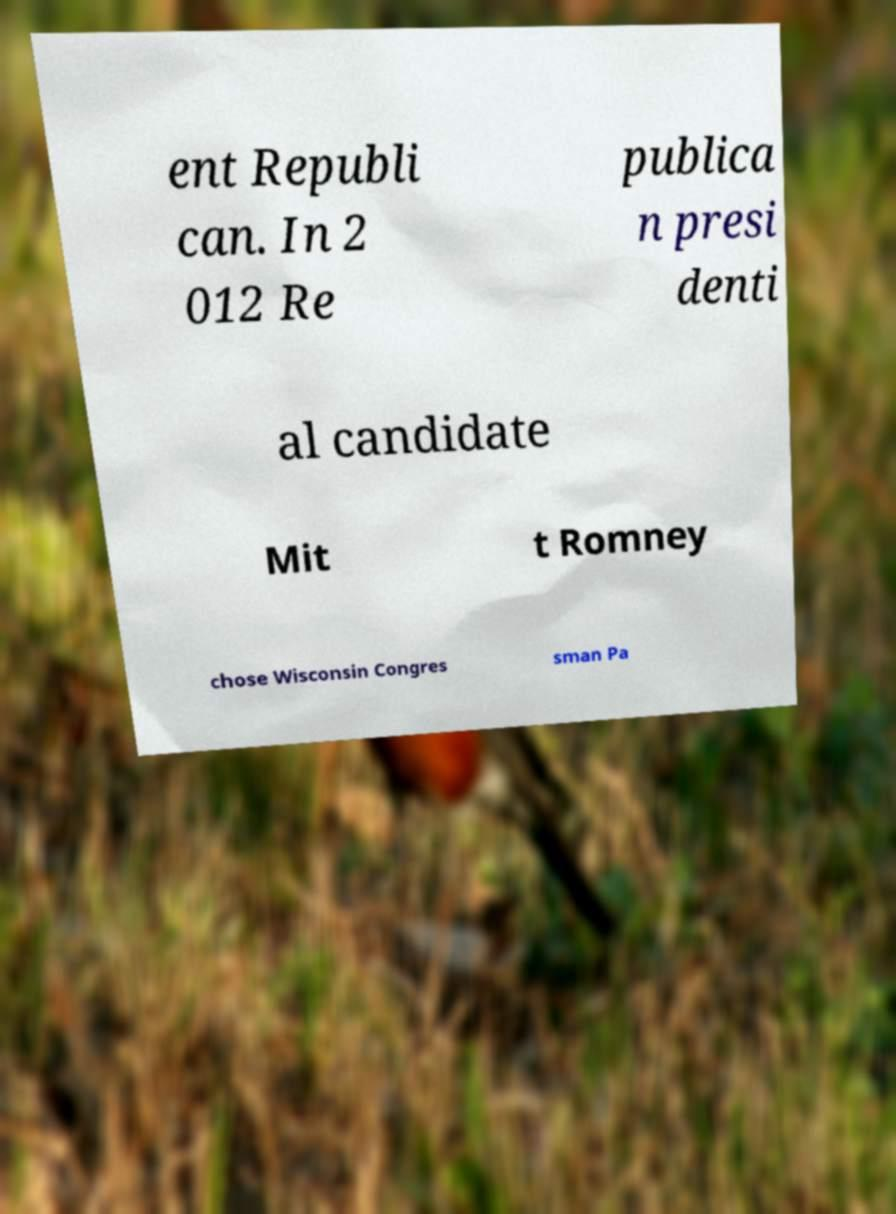Could you assist in decoding the text presented in this image and type it out clearly? ent Republi can. In 2 012 Re publica n presi denti al candidate Mit t Romney chose Wisconsin Congres sman Pa 